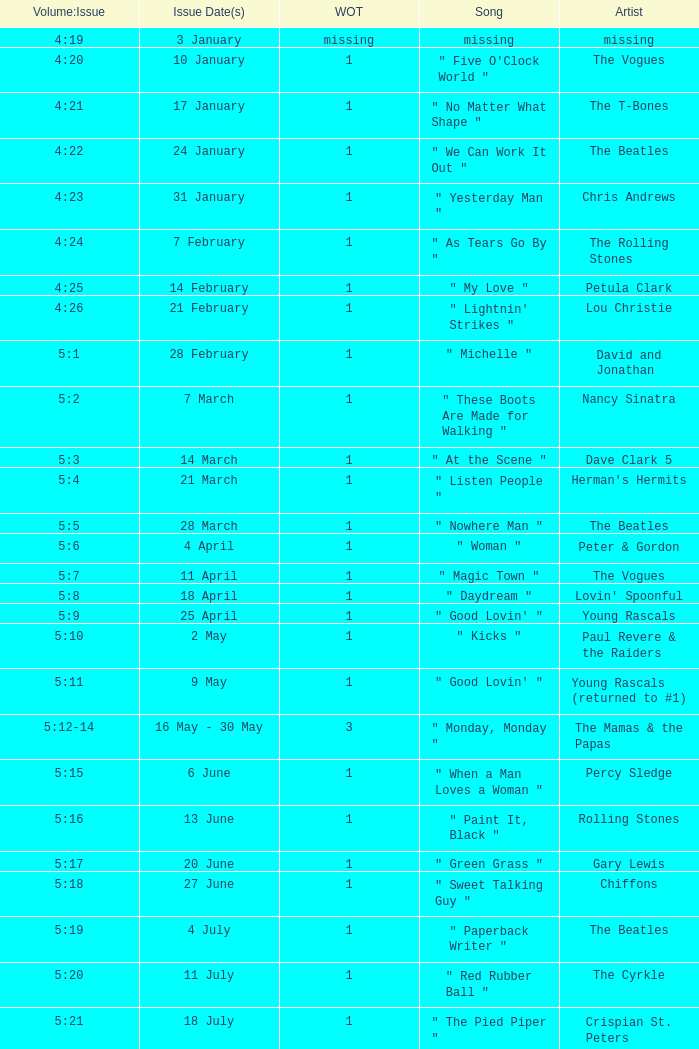Parse the table in full. {'header': ['Volume:Issue', 'Issue Date(s)', 'WOT', 'Song', 'Artist'], 'rows': [['4:19', '3 January', 'missing', 'missing', 'missing'], ['4:20', '10 January', '1', '" Five O\'Clock World "', 'The Vogues'], ['4:21', '17 January', '1', '" No Matter What Shape "', 'The T-Bones'], ['4:22', '24 January', '1', '" We Can Work It Out "', 'The Beatles'], ['4:23', '31 January', '1', '" Yesterday Man "', 'Chris Andrews'], ['4:24', '7 February', '1', '" As Tears Go By "', 'The Rolling Stones'], ['4:25', '14 February', '1', '" My Love "', 'Petula Clark'], ['4:26', '21 February', '1', '" Lightnin\' Strikes "', 'Lou Christie'], ['5:1', '28 February', '1', '" Michelle "', 'David and Jonathan'], ['5:2', '7 March', '1', '" These Boots Are Made for Walking "', 'Nancy Sinatra'], ['5:3', '14 March', '1', '" At the Scene "', 'Dave Clark 5'], ['5:4', '21 March', '1', '" Listen People "', "Herman's Hermits"], ['5:5', '28 March', '1', '" Nowhere Man "', 'The Beatles'], ['5:6', '4 April', '1', '" Woman "', 'Peter & Gordon'], ['5:7', '11 April', '1', '" Magic Town "', 'The Vogues'], ['5:8', '18 April', '1', '" Daydream "', "Lovin' Spoonful"], ['5:9', '25 April', '1', '" Good Lovin\' "', 'Young Rascals'], ['5:10', '2 May', '1', '" Kicks "', 'Paul Revere & the Raiders'], ['5:11', '9 May', '1', '" Good Lovin\' "', 'Young Rascals (returned to #1)'], ['5:12-14', '16 May - 30 May', '3', '" Monday, Monday "', 'The Mamas & the Papas'], ['5:15', '6 June', '1', '" When a Man Loves a Woman "', 'Percy Sledge'], ['5:16', '13 June', '1', '" Paint It, Black "', 'Rolling Stones'], ['5:17', '20 June', '1', '" Green Grass "', 'Gary Lewis'], ['5:18', '27 June', '1', '" Sweet Talking Guy "', 'Chiffons'], ['5:19', '4 July', '1', '" Paperback Writer "', 'The Beatles'], ['5:20', '11 July', '1', '" Red Rubber Ball "', 'The Cyrkle'], ['5:21', '18 July', '1', '" The Pied Piper "', 'Crispian St. Peters'], ['5:22', '25 July', '1', '" Hanky Panky "', 'Tommy James and the Shondells'], ['5:23', '1 August', '1', '" Sweet Pea "', 'Tommy Roe'], ['5:24', '8 August', '1', '" I Saw Her Again "', 'The Mamas & the Papas'], ['5:25-26', '15 August - 22 August', '2', '" Summer in the City "', "Lovin' Spoonful"], ['6:1', '29 August', '1', '" See You in September "', 'The Happenings'], ['6:2', '5 September', '1', '" Bus Stop "', 'The Hollies'], ['6:3', '12 September', '1', '" Get Away "', 'Georgie Fame'], ['6:4', '19 September', '1', '" Yellow Submarine "/" Eleanor Rigby "', 'The Beatles'], ['6:5', '26 September', '1', '" Sunny Afternoon "', 'The Kinks'], ['6:6', '3 October', '1', '" Cherish "', 'The Association'], ['6:7', '10 October', '1', '" Black Is Black "', 'Los Bravos'], ['6:8-9', '17 October - 24 October', '2', '" See See Rider "', 'Eric Burdon and The Animals'], ['6:10', '31 October', '1', '" 96 Tears "', 'Question Mark & the Mysterians'], ['6:11', '7 November', '1', '" Last Train to Clarksville "', 'The Monkees'], ['6:12', '14 November', '1', '" Dandy "', "Herman's Hermits"], ['6:13', '21 November', '1', '" Poor Side of Town "', 'Johnny Rivers'], ['6:14-15', '28 November - 5 December', '2', '" Winchester Cathedral "', 'New Vaudeville Band'], ['6:16', '12 December', '1', '" Lady Godiva "', 'Peter & Gordon'], ['6:17', '19 December', '1', '" Stop! Stop! Stop! "', 'The Hollies'], ['6:18-19', '26 December - 2 January', '2', '" I\'m a Believer "', 'The Monkees']]} With an issue date(s) of 12 September, what is in the column for Weeks on Top? 1.0. 